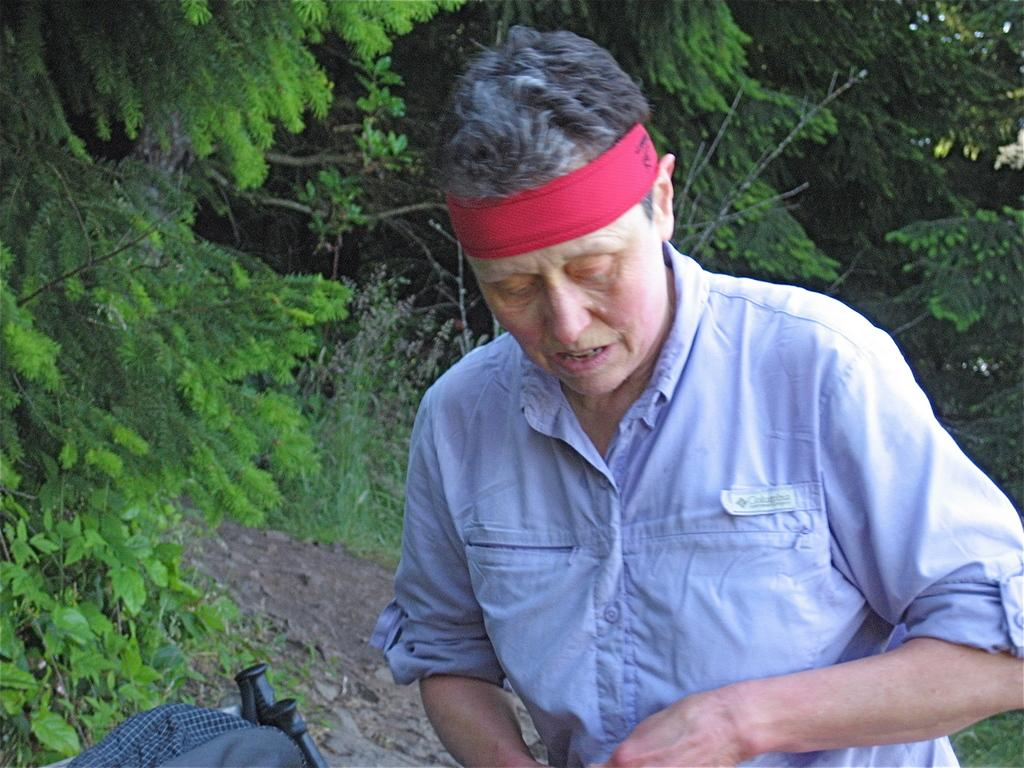What is the main subject of the image? There is a person standing in the center of the image. What can be seen in the background of the image? There are trees in the background of the image. Where is the harbor located in the image? There is no harbor present in the image. Is the person in the image twisting or playing volleyball? The image does not show the person twisting or playing volleyball; they are simply standing in the center. 